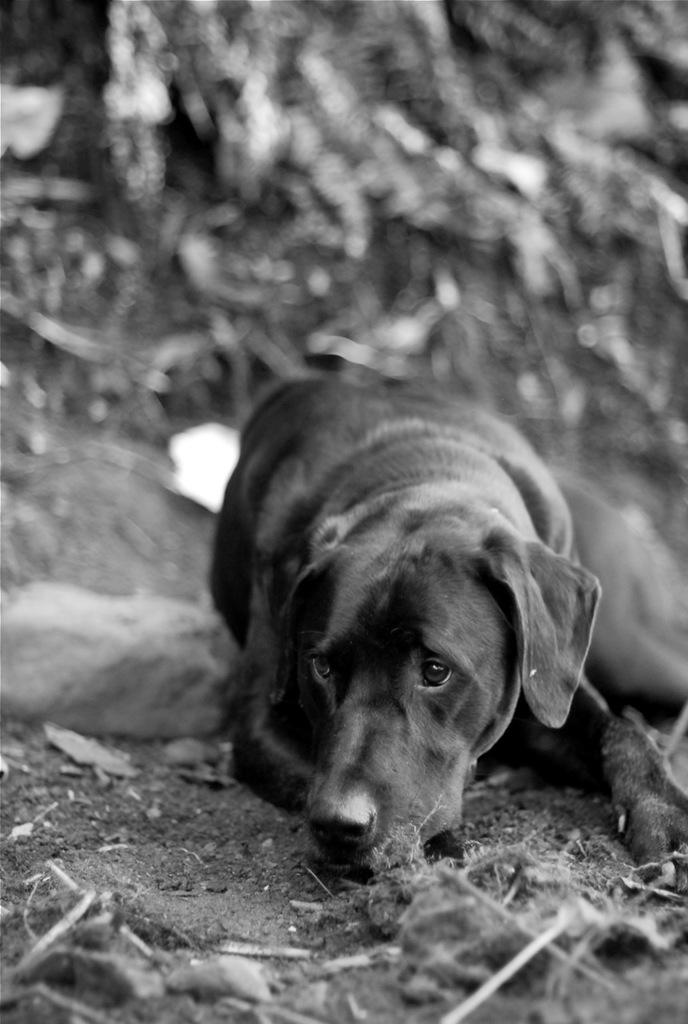What type of animal is in the image? There is a dog in the image. Where is the dog located? The dog is laying on the land. What advice does the dog's grandfather give in the image? There is no mention of a grandfather or any advice in the image; it simply shows a dog laying on the land. 